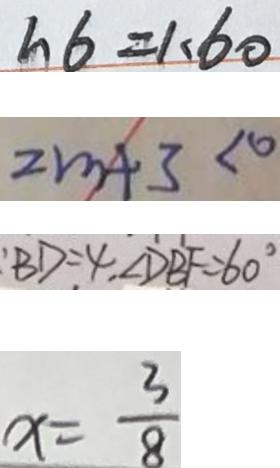Convert formula to latex. <formula><loc_0><loc_0><loc_500><loc_500>h 6 = 1 . 6 0 
 2 m + 3 < 0 
 : B D = 4 , \angle D B F = 6 0 ^ { \circ } 
 x = \frac { 3 } { 8 }</formula> 